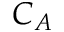Convert formula to latex. <formula><loc_0><loc_0><loc_500><loc_500>C _ { A }</formula> 